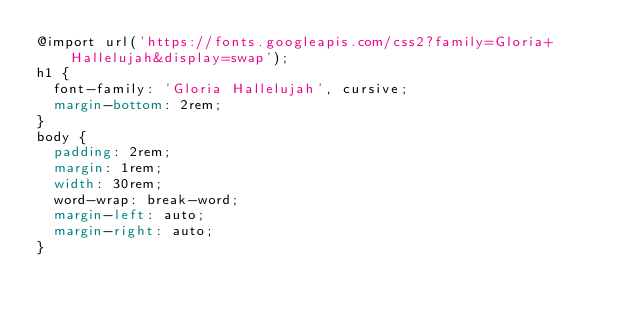<code> <loc_0><loc_0><loc_500><loc_500><_CSS_>@import url('https://fonts.googleapis.com/css2?family=Gloria+Hallelujah&display=swap');
h1 {
  font-family: 'Gloria Hallelujah', cursive;
  margin-bottom: 2rem;
}
body {
  padding: 2rem;
  margin: 1rem;
  width: 30rem;
  word-wrap: break-word;
  margin-left: auto;
  margin-right: auto;
}
</code> 